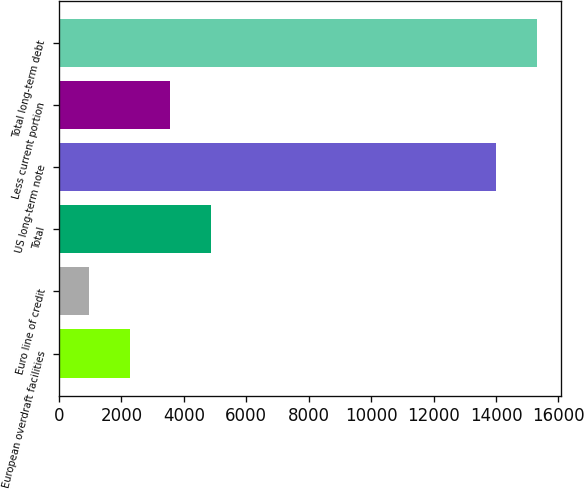Convert chart to OTSL. <chart><loc_0><loc_0><loc_500><loc_500><bar_chart><fcel>European overdraft facilities<fcel>Euro line of credit<fcel>Total<fcel>US long-term note<fcel>Less current portion<fcel>Total long-term debt<nl><fcel>2261.8<fcel>956<fcel>4873.4<fcel>14000<fcel>3567.6<fcel>15305.8<nl></chart> 